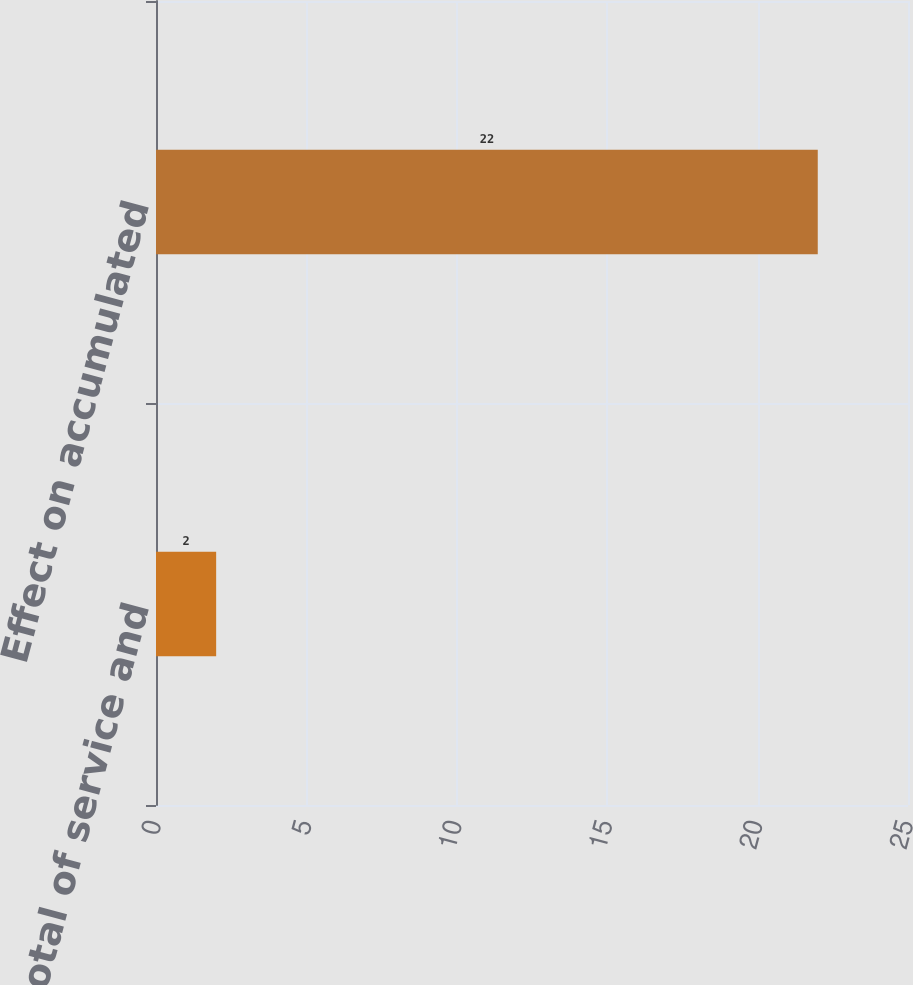Convert chart. <chart><loc_0><loc_0><loc_500><loc_500><bar_chart><fcel>Effect on total of service and<fcel>Effect on accumulated<nl><fcel>2<fcel>22<nl></chart> 